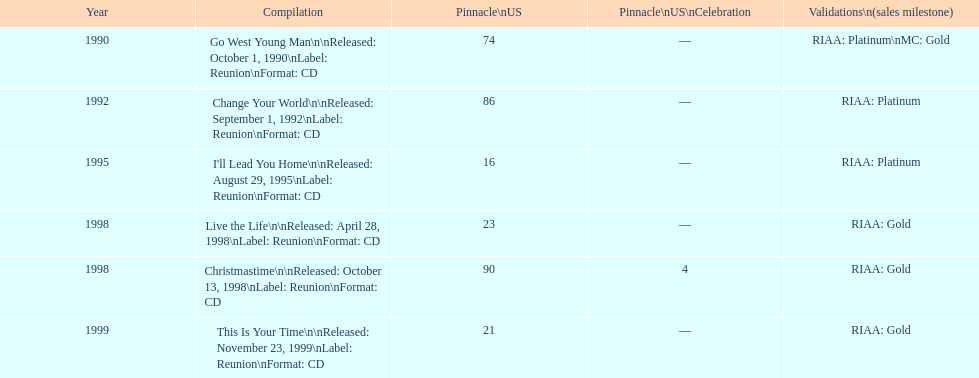Riaa: gold is only one of the certifications, but what is the other? Platinum. 